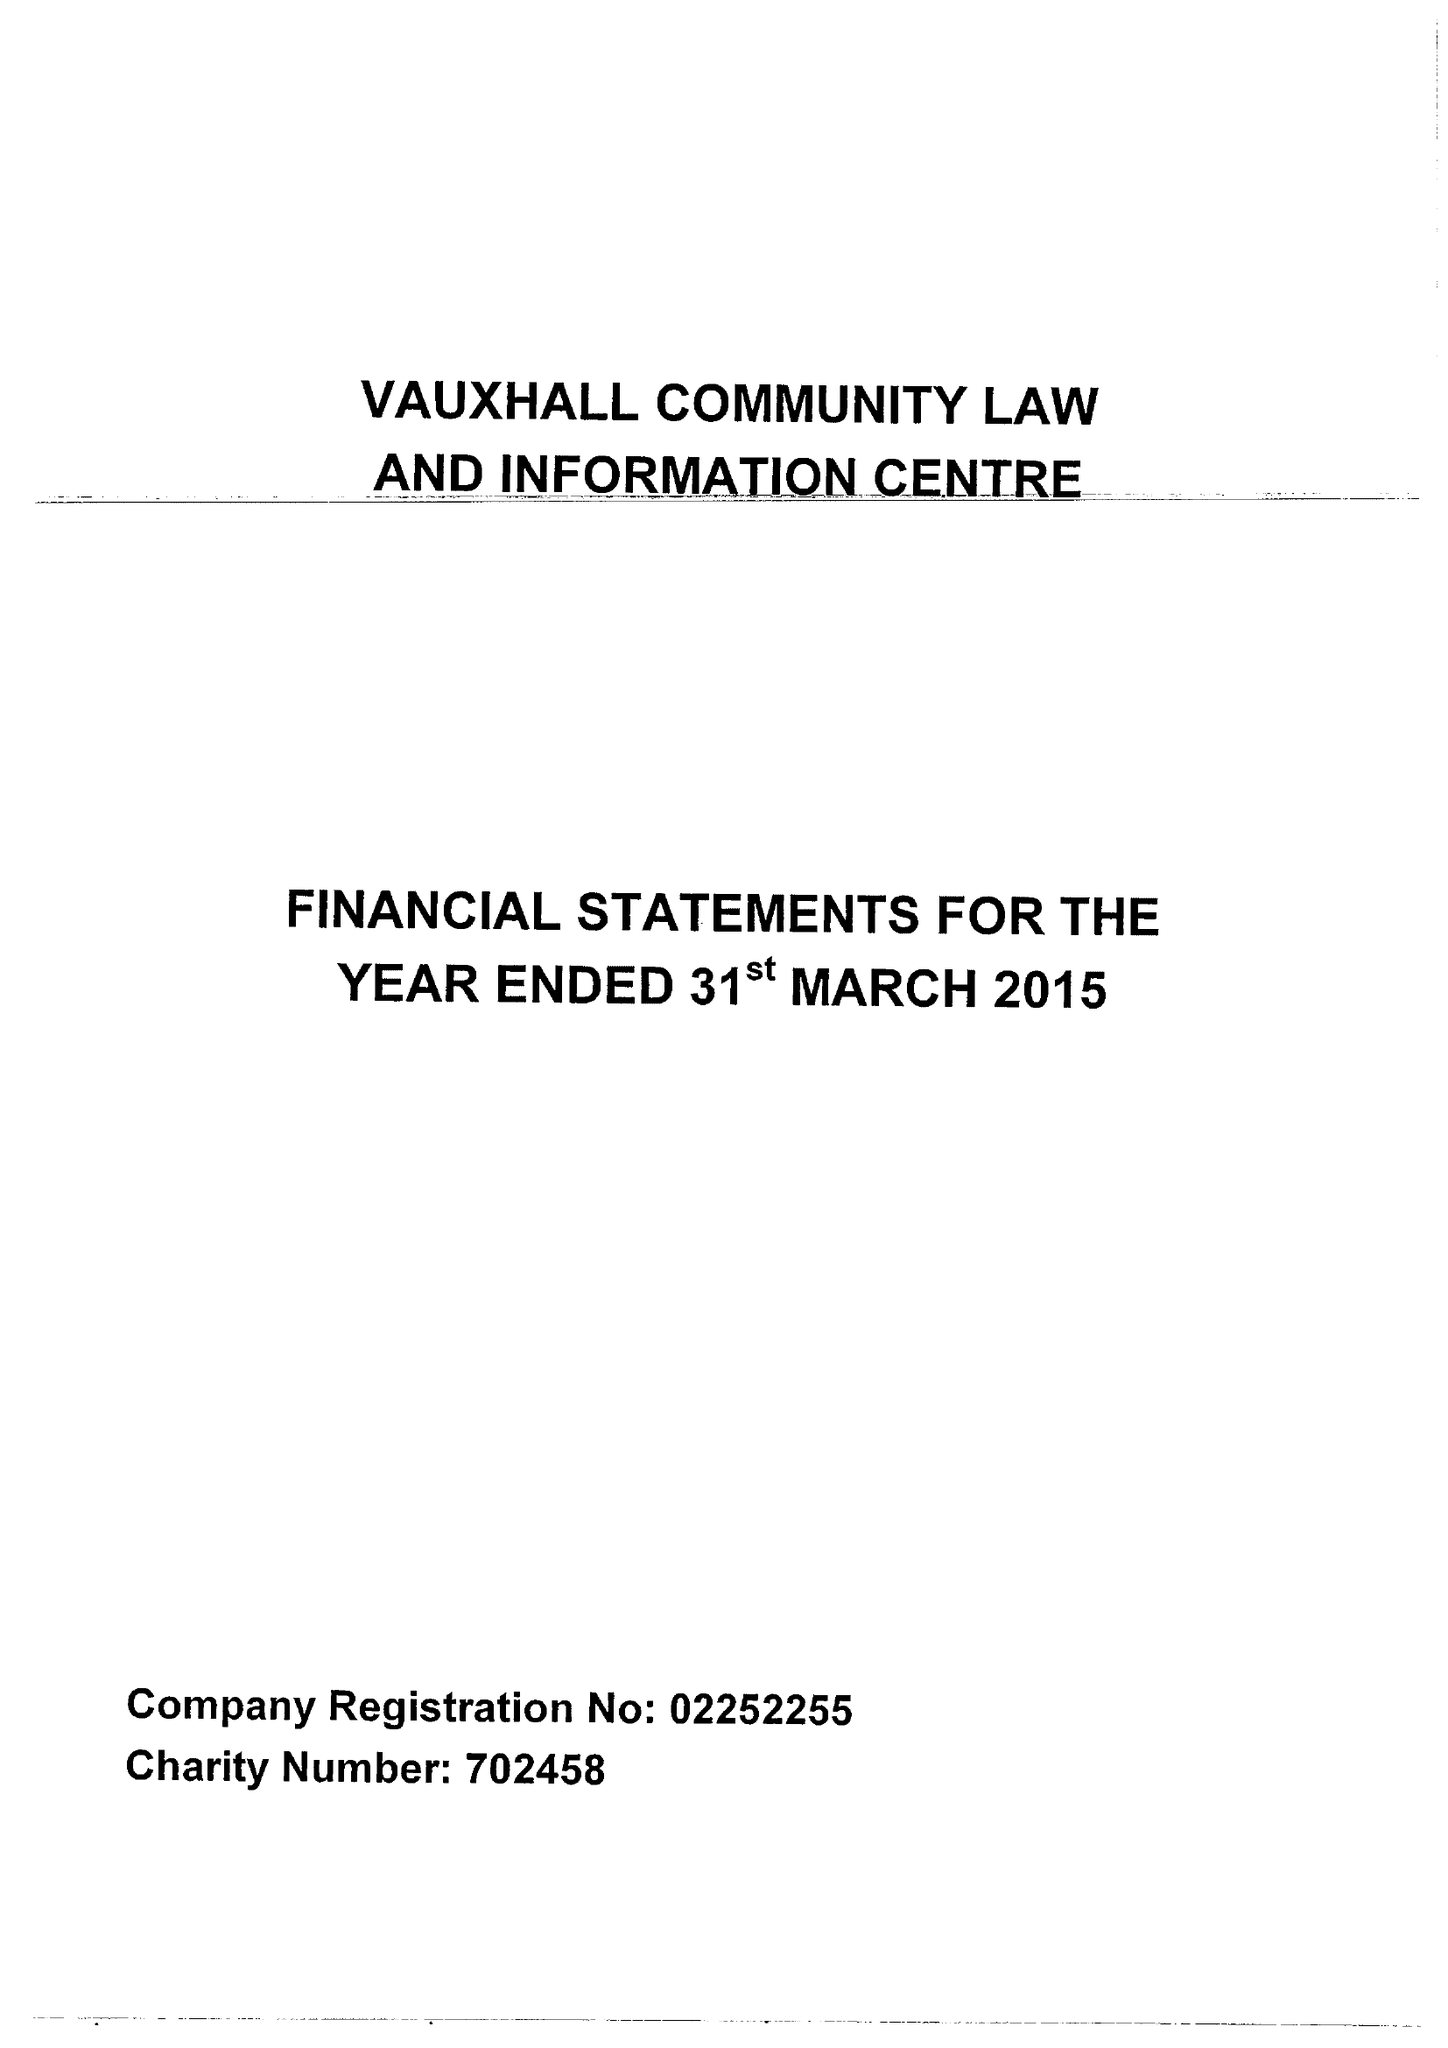What is the value for the charity_number?
Answer the question using a single word or phrase. 702458 